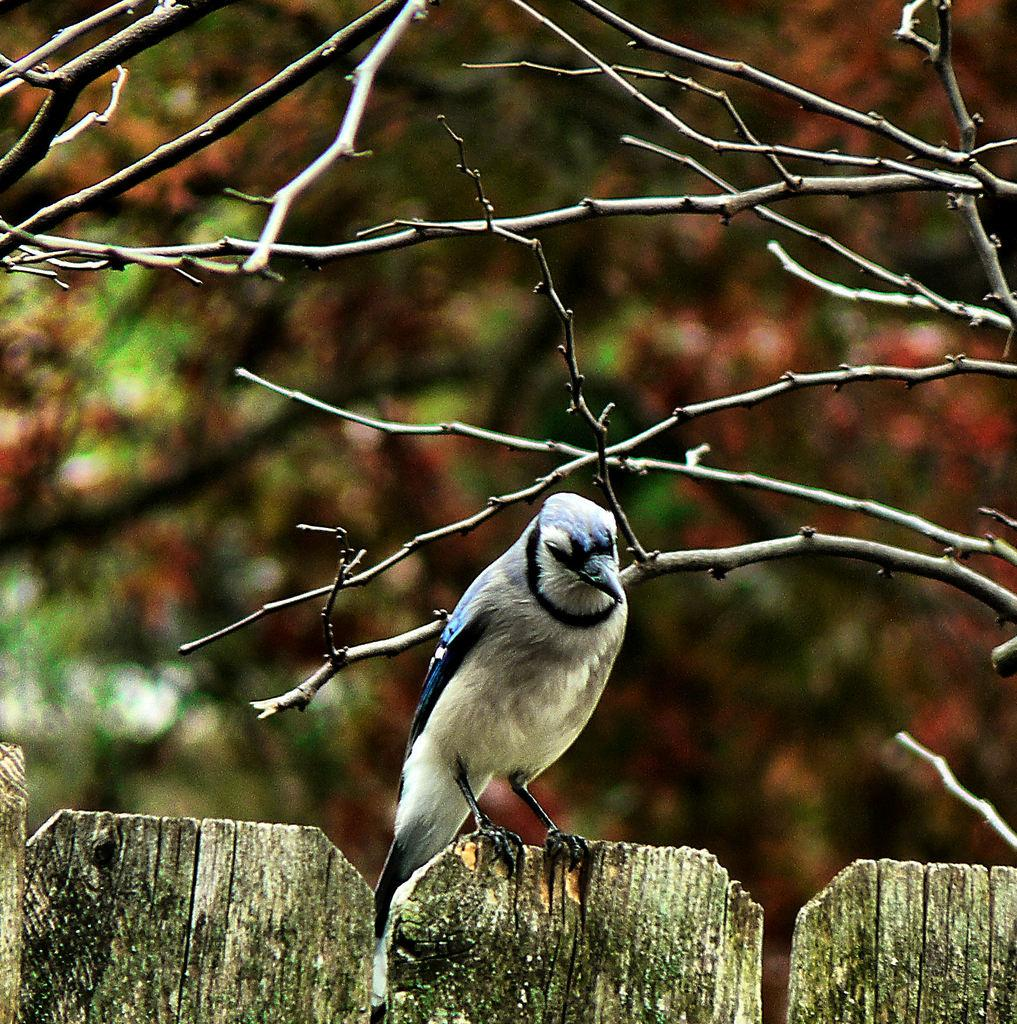What is the main subject of the image? There is a bird in the center of the image. Where is the bird located? The bird is on a wooden boundary. What can be seen in the background of the image? There are trees in the background of the image. What type of pancake is the bird holding in its beak? There is no pancake present in the image, and the bird is not holding anything in its beak. 